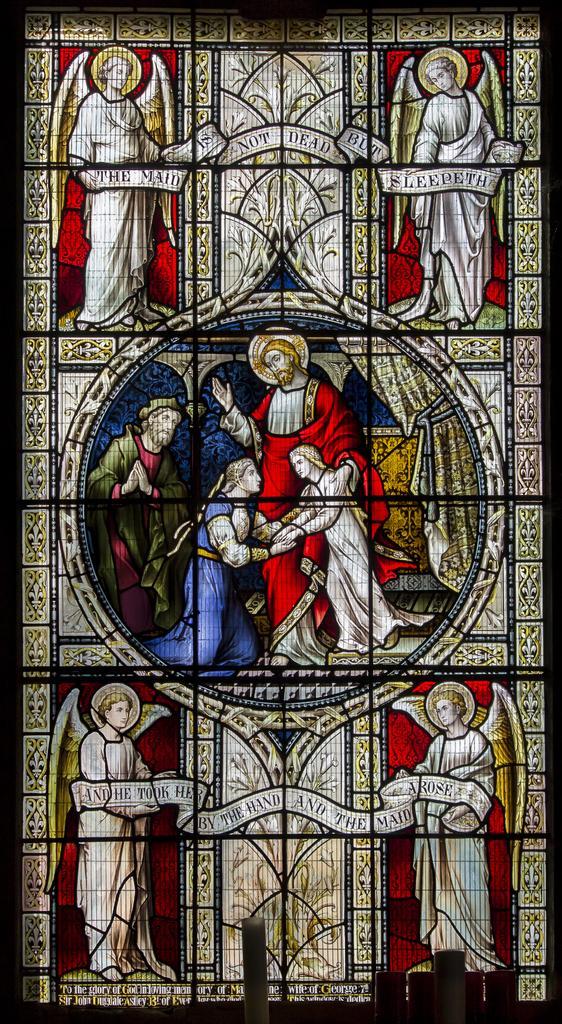In one or two sentences, can you explain what this image depicts? In this image we can see painting on the glass. 